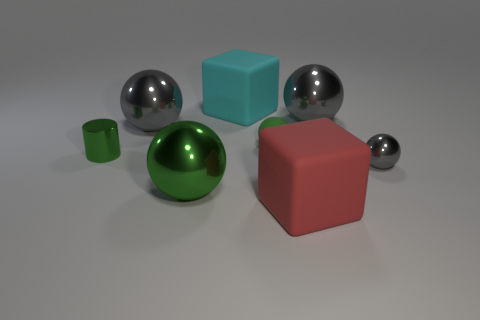Do the gray metallic thing that is on the left side of the cyan matte thing and the small gray shiny sphere have the same size?
Provide a succinct answer. No. Are the tiny green cylinder and the cube behind the red object made of the same material?
Make the answer very short. No. Is there a gray sphere that has the same size as the green shiny sphere?
Offer a terse response. Yes. There is a green thing that is right of the large cyan cube; does it have the same shape as the big red matte object?
Your answer should be compact. No. What color is the small shiny sphere?
Provide a succinct answer. Gray. What shape is the matte object that is the same color as the cylinder?
Keep it short and to the point. Sphere. Is there a blue metallic cylinder?
Provide a succinct answer. No. What is the size of the green thing that is the same material as the large red thing?
Provide a succinct answer. Small. What is the shape of the gray shiny thing in front of the big gray metallic thing that is left of the block in front of the tiny green cylinder?
Offer a terse response. Sphere. Is the number of big metal spheres behind the tiny green metallic cylinder the same as the number of shiny balls?
Your response must be concise. No. 